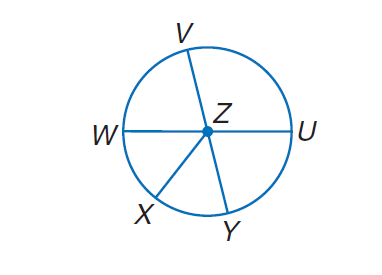Answer the mathemtical geometry problem and directly provide the correct option letter.
Question: In \odot Z, \angle W Z X \cong \angle X Z Y, m \angle V Z U = 4 x, m \angle U Z Y = 2 x + 24, and V Y and W U are diameters. Find m \widehat W X.
Choices: A: 48 B: 52 C: 90 D: 180 B 